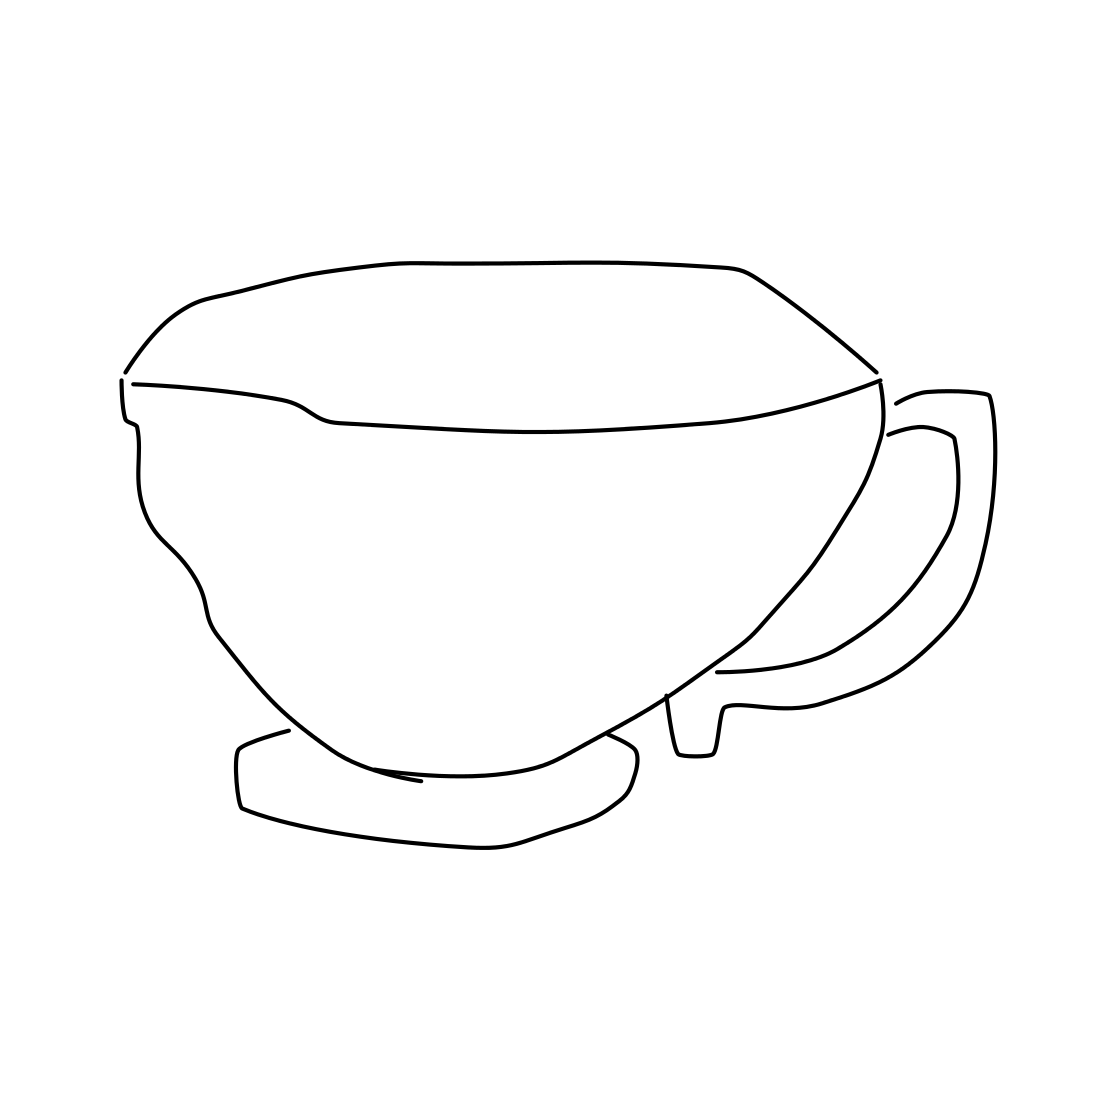Could you suggest a setting or occasion where this cup might be used? This cup would be well-suited for a contemporary cafe setting, perched on a saucer beside a freshly baked croissant, or at a casual brunch among friends who appreciate modern aesthetics. 